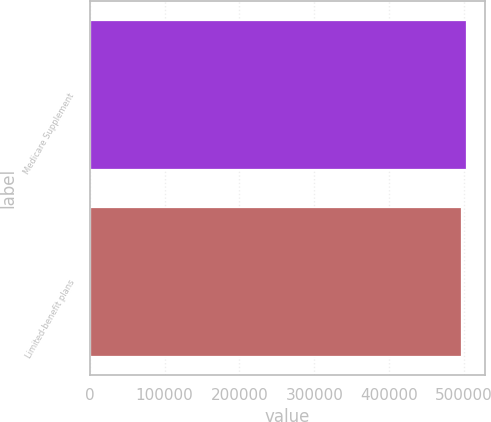Convert chart. <chart><loc_0><loc_0><loc_500><loc_500><bar_chart><fcel>Medicare Supplement<fcel>Limited-benefit plans<nl><fcel>502691<fcel>495943<nl></chart> 